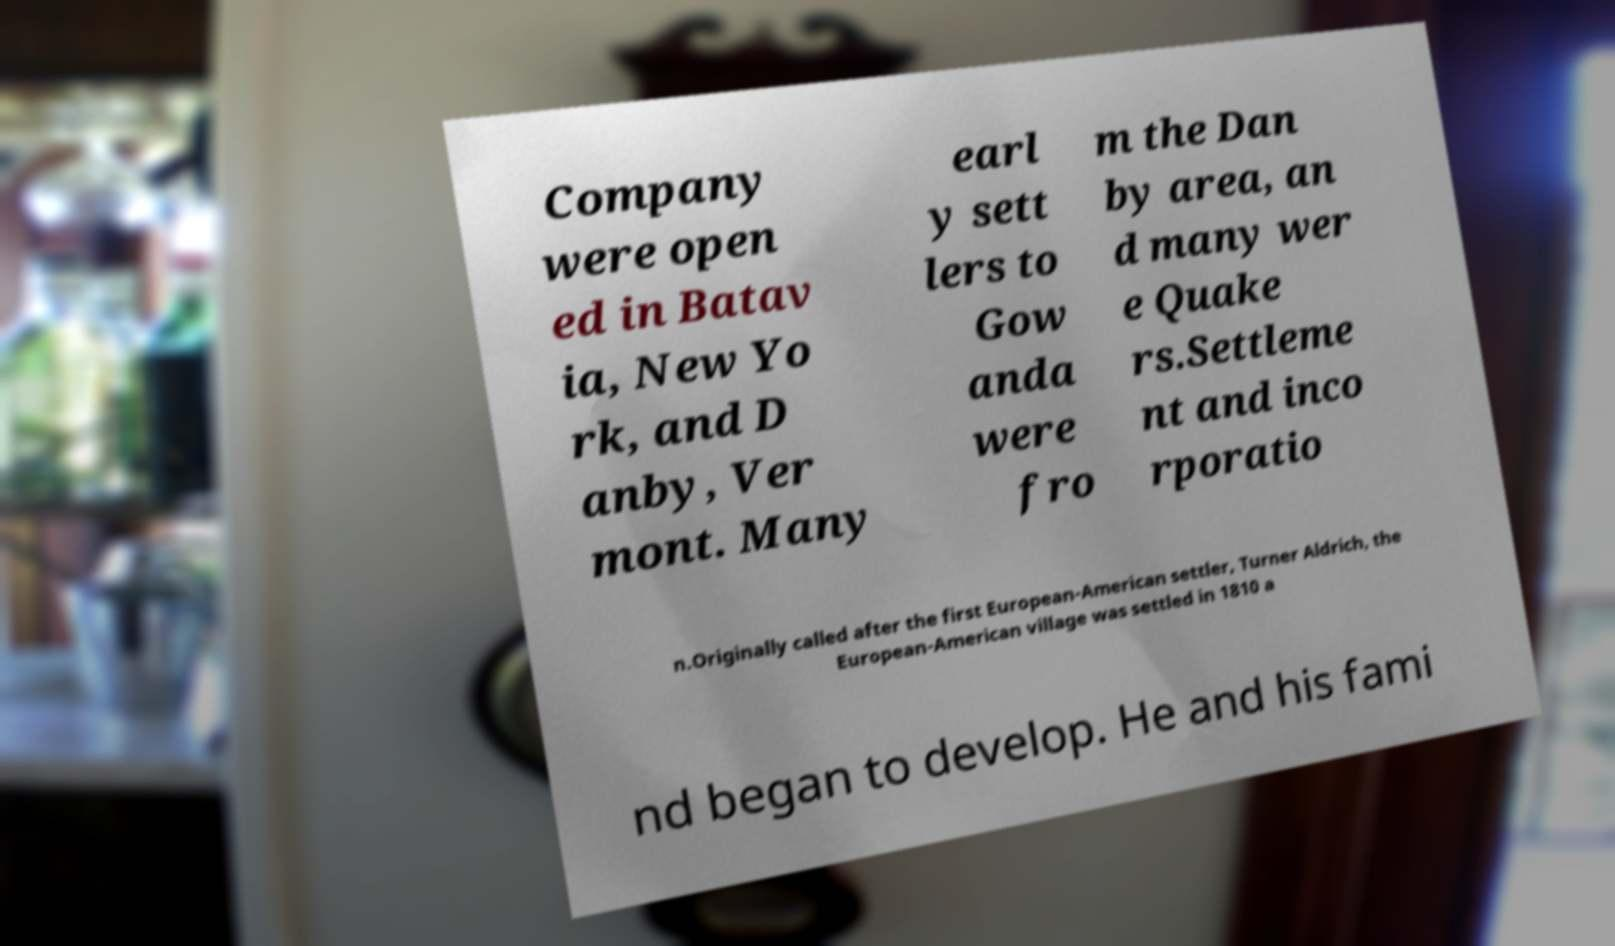Please identify and transcribe the text found in this image. Company were open ed in Batav ia, New Yo rk, and D anby, Ver mont. Many earl y sett lers to Gow anda were fro m the Dan by area, an d many wer e Quake rs.Settleme nt and inco rporatio n.Originally called after the first European-American settler, Turner Aldrich, the European-American village was settled in 1810 a nd began to develop. He and his fami 